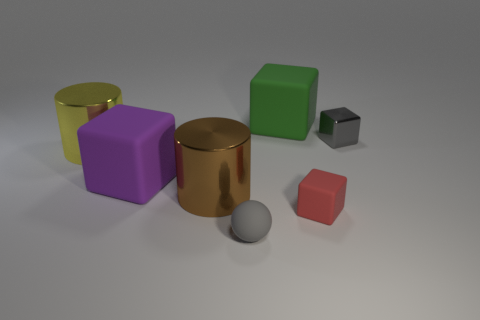Is the number of yellow metal balls greater than the number of small gray shiny cubes?
Your answer should be very brief. No. What is the material of the large green thing?
Your answer should be very brief. Rubber. There is a gray thing that is behind the large brown shiny cylinder; what number of big cylinders are on the left side of it?
Keep it short and to the point. 2. There is a ball; does it have the same color as the tiny metal thing that is behind the red rubber object?
Give a very brief answer. Yes. There is a block that is the same size as the green thing; what color is it?
Your answer should be very brief. Purple. Are there any red rubber objects of the same shape as the large yellow thing?
Your response must be concise. No. Is the number of purple cubes less than the number of yellow spheres?
Offer a very short reply. No. The metallic thing on the right side of the small red rubber thing is what color?
Give a very brief answer. Gray. What shape is the tiny object that is behind the cylinder that is behind the large purple object?
Provide a succinct answer. Cube. Is the tiny sphere made of the same material as the tiny red block on the right side of the big green rubber thing?
Provide a short and direct response. Yes. 